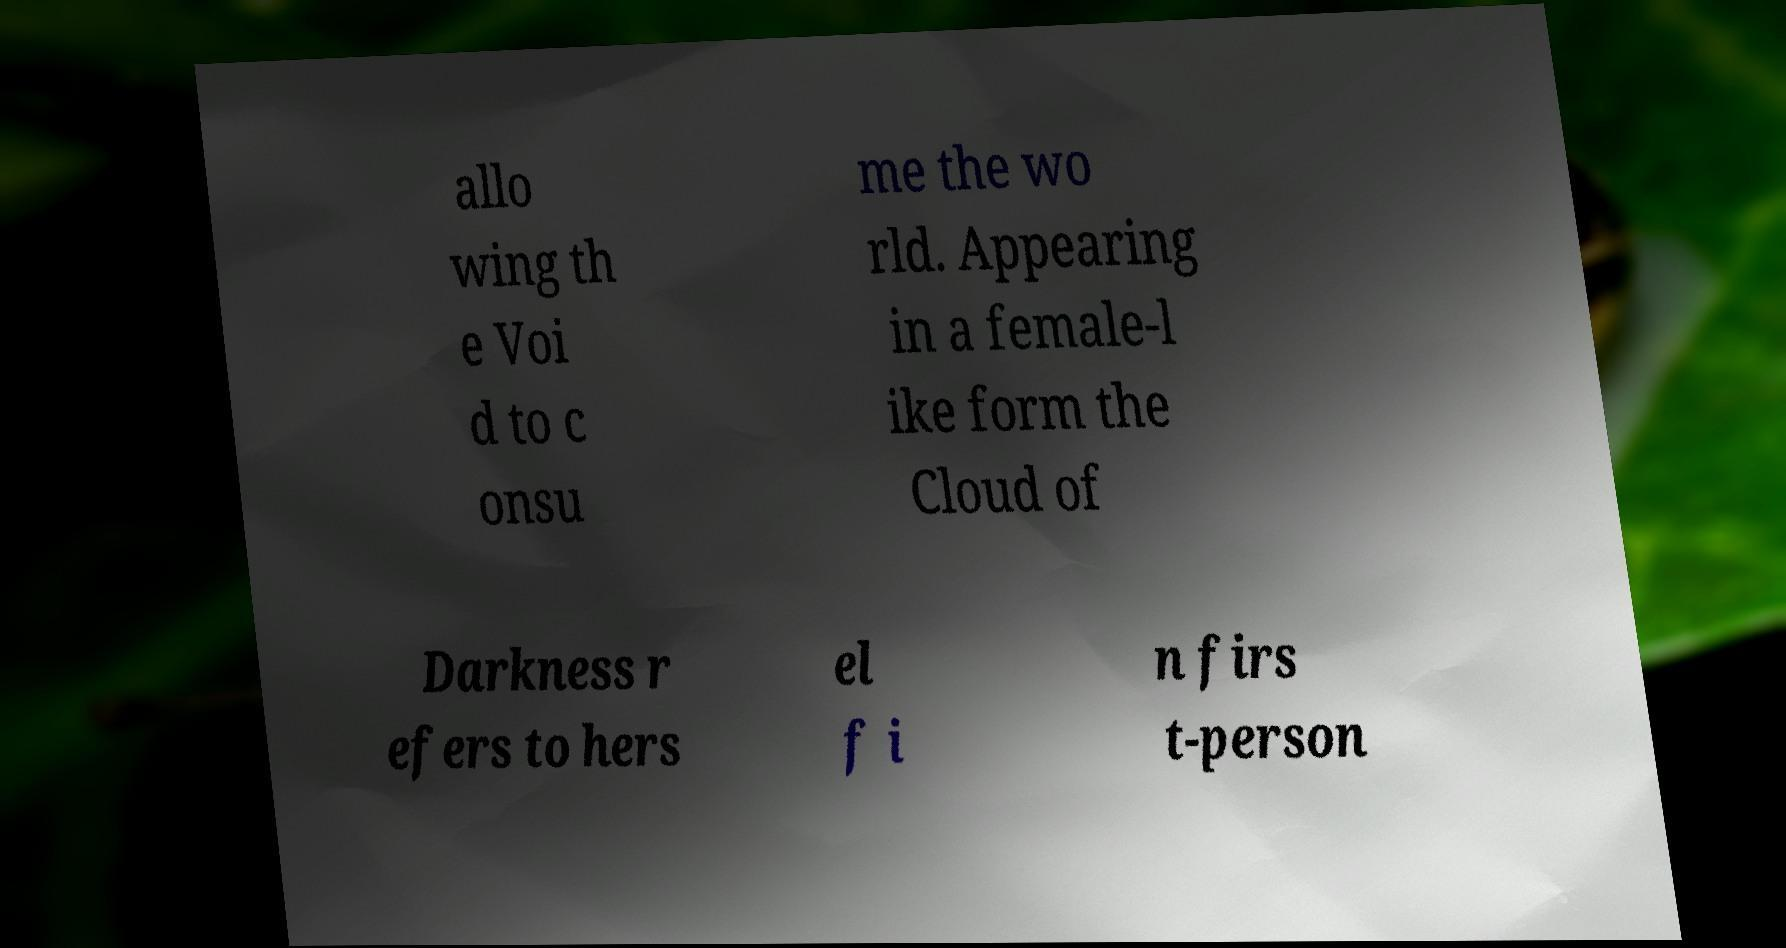Please identify and transcribe the text found in this image. allo wing th e Voi d to c onsu me the wo rld. Appearing in a female-l ike form the Cloud of Darkness r efers to hers el f i n firs t-person 